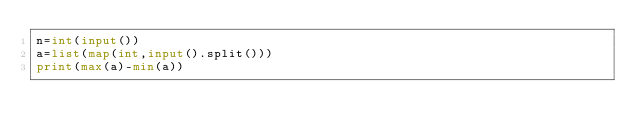<code> <loc_0><loc_0><loc_500><loc_500><_Python_>n=int(input())
a=list(map(int,input().split()))
print(max(a)-min(a))</code> 